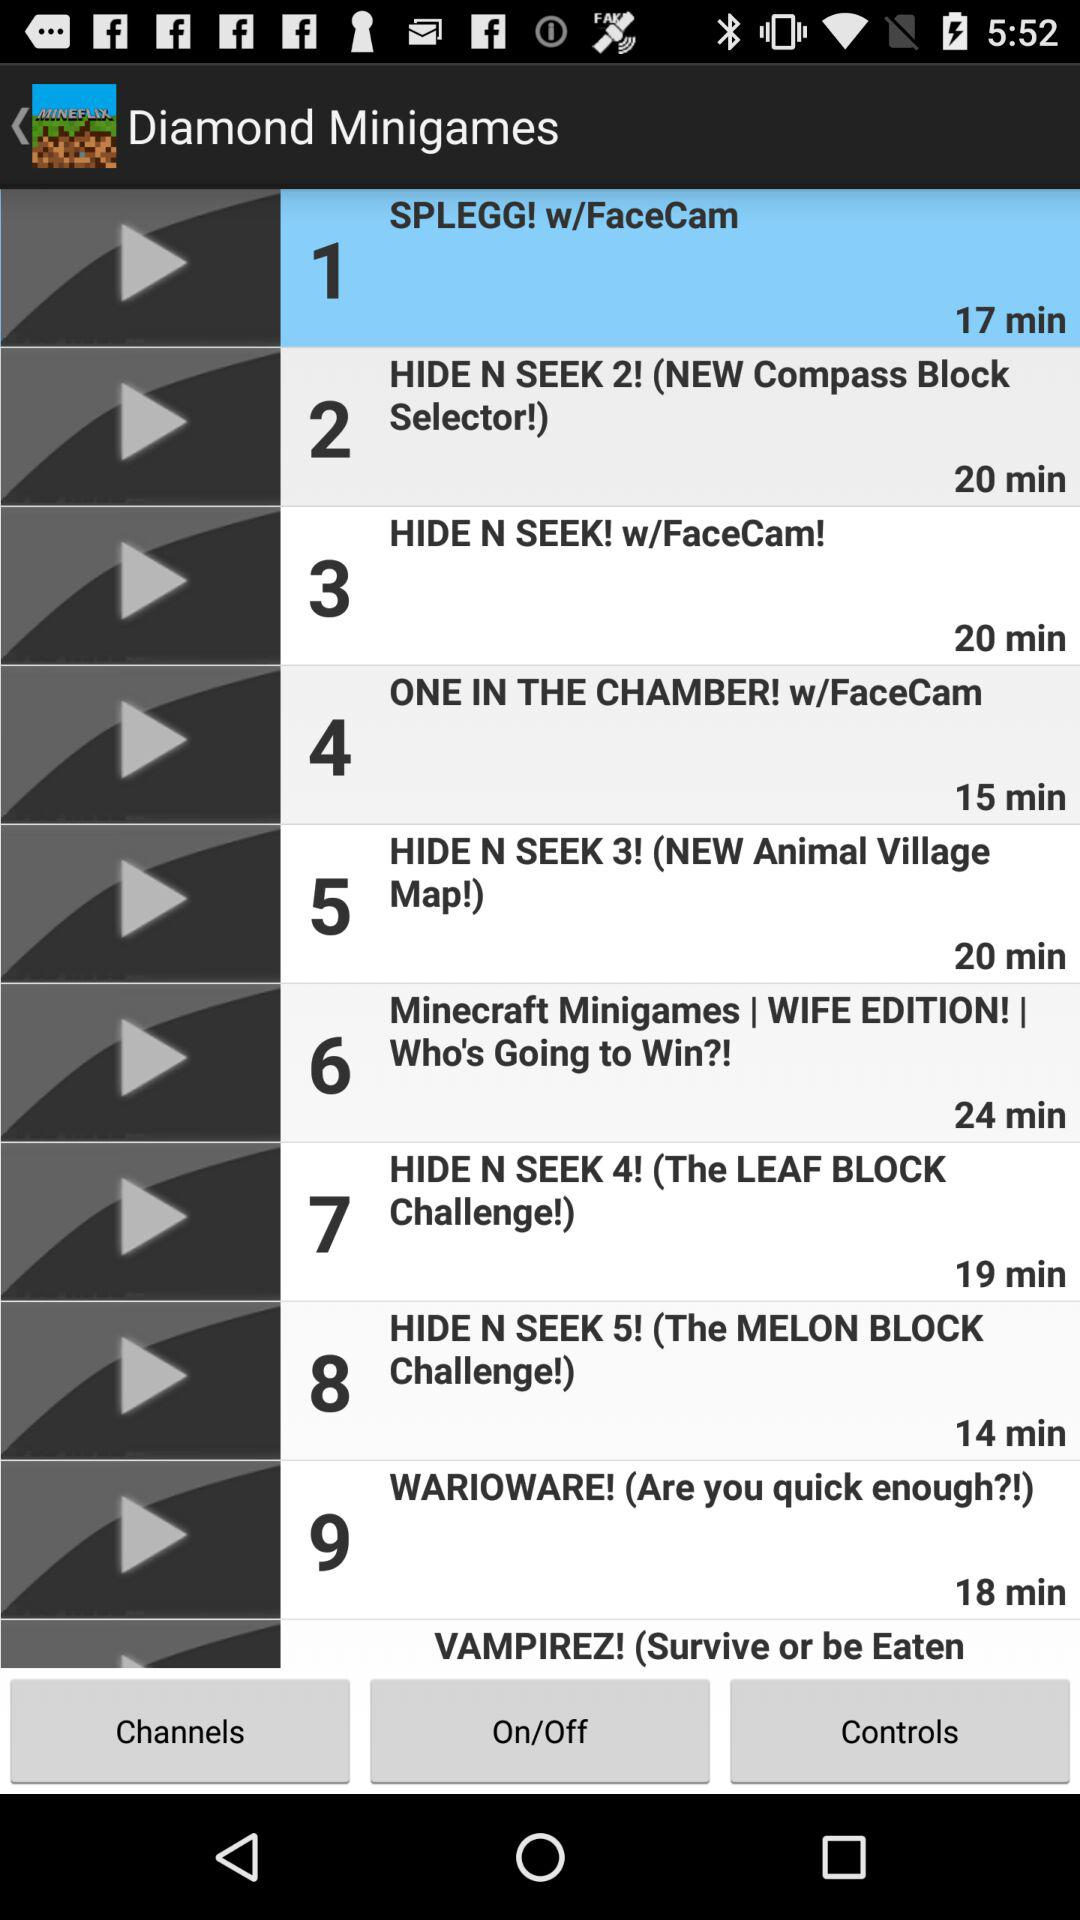What is the duration of "HIDE N SEEK! w/FaceCam!"? The duration is 20 minutes. 